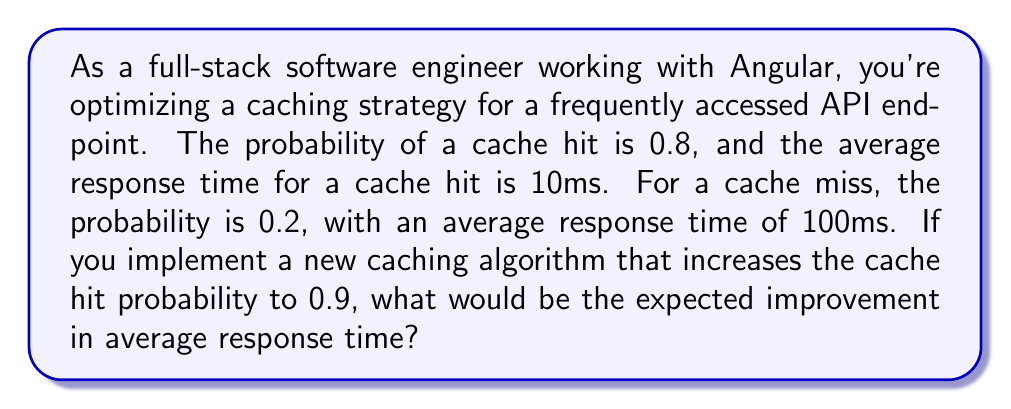Show me your answer to this math problem. Let's approach this step-by-step:

1) First, let's calculate the current expected response time:

   $$E(\text{current}) = 0.8 \cdot 10\text{ms} + 0.2 \cdot 100\text{ms}$$
   $$E(\text{current}) = 8\text{ms} + 20\text{ms} = 28\text{ms}$$

2) Now, let's calculate the expected response time with the new caching algorithm:

   $$E(\text{new}) = 0.9 \cdot 10\text{ms} + 0.1 \cdot 100\text{ms}$$
   $$E(\text{new}) = 9\text{ms} + 10\text{ms} = 19\text{ms}$$

3) To find the improvement, we subtract the new expected time from the current:

   $$\text{Improvement} = E(\text{current}) - E(\text{new})$$
   $$\text{Improvement} = 28\text{ms} - 19\text{ms} = 9\text{ms}$$

This improvement can be expressed as a percentage:

$$\text{Percentage Improvement} = \frac{\text{Improvement}}{E(\text{current})} \cdot 100\%$$
$$\text{Percentage Improvement} = \frac{9\text{ms}}{28\text{ms}} \cdot 100\% \approx 32.14\%$$
Answer: The expected improvement in average response time is 9ms, or approximately 32.14%. 